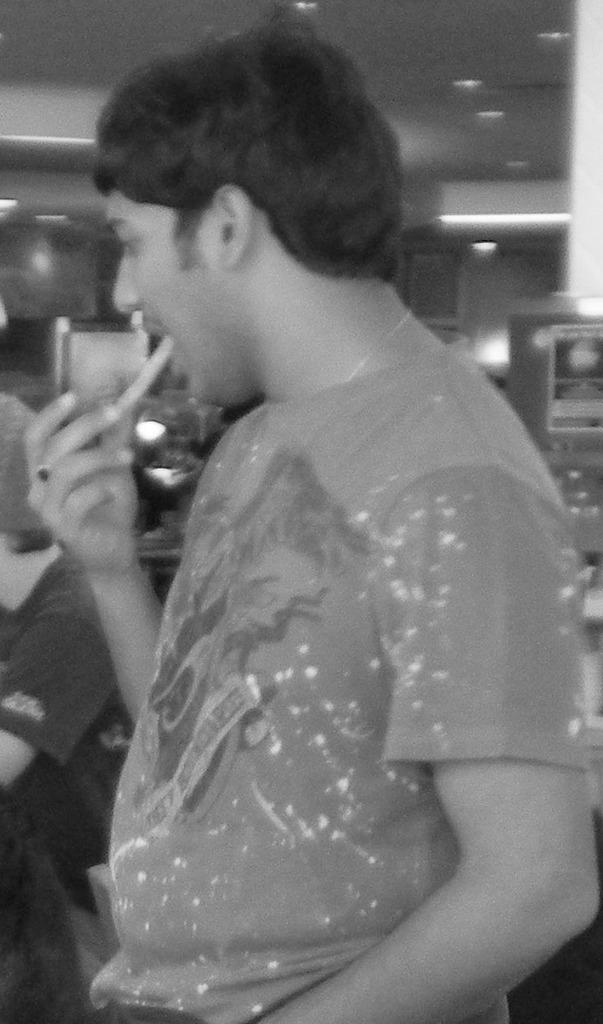What is the main subject in the center of the image? There is a man standing in the center of the image. What is the position of the person on the left side of the image? There is a person sitting on the left side of the image. What can be seen in the background of the image? There is a wall in the background of the image. What is visible at the top of the image? There are lights visible at the top of the image. How many books are being read by the person sitting on the left side of the image? There are no books visible in the image, so it cannot be determined how many books the person might be reading. 